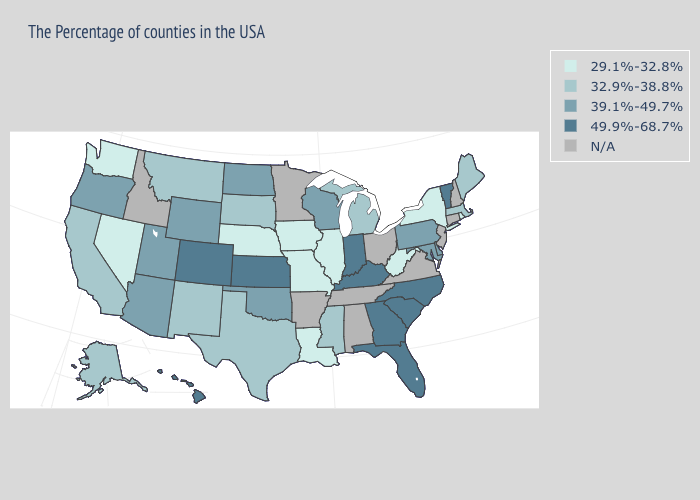Name the states that have a value in the range 49.9%-68.7%?
Short answer required. Vermont, North Carolina, South Carolina, Florida, Georgia, Kentucky, Indiana, Kansas, Colorado, Hawaii. Name the states that have a value in the range N/A?
Quick response, please. New Hampshire, Connecticut, New Jersey, Virginia, Ohio, Alabama, Tennessee, Arkansas, Minnesota, Idaho. Which states have the highest value in the USA?
Quick response, please. Vermont, North Carolina, South Carolina, Florida, Georgia, Kentucky, Indiana, Kansas, Colorado, Hawaii. Does the first symbol in the legend represent the smallest category?
Be succinct. Yes. What is the highest value in states that border Texas?
Be succinct. 39.1%-49.7%. Among the states that border North Dakota , which have the lowest value?
Give a very brief answer. South Dakota, Montana. Name the states that have a value in the range 39.1%-49.7%?
Quick response, please. Delaware, Maryland, Pennsylvania, Wisconsin, Oklahoma, North Dakota, Wyoming, Utah, Arizona, Oregon. Which states have the lowest value in the USA?
Answer briefly. Rhode Island, New York, West Virginia, Illinois, Louisiana, Missouri, Iowa, Nebraska, Nevada, Washington. Is the legend a continuous bar?
Be succinct. No. What is the highest value in states that border Illinois?
Keep it brief. 49.9%-68.7%. What is the value of North Dakota?
Quick response, please. 39.1%-49.7%. Name the states that have a value in the range N/A?
Give a very brief answer. New Hampshire, Connecticut, New Jersey, Virginia, Ohio, Alabama, Tennessee, Arkansas, Minnesota, Idaho. Name the states that have a value in the range 49.9%-68.7%?
Short answer required. Vermont, North Carolina, South Carolina, Florida, Georgia, Kentucky, Indiana, Kansas, Colorado, Hawaii. Does West Virginia have the lowest value in the South?
Short answer required. Yes. 